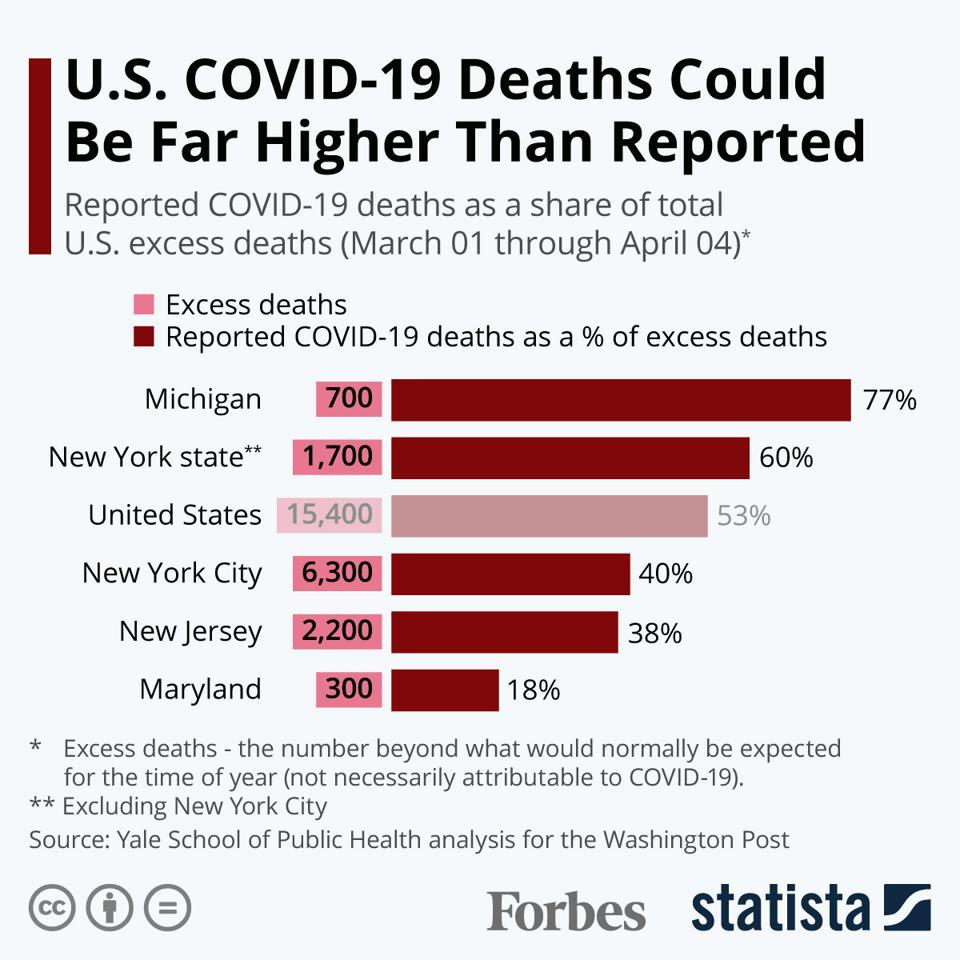Give some essential details in this illustration. According to the bar graph, in three places, the percentage of reported COVID-19 deaths is below 50%. The bar graph shows the number of excess deaths in different places, and in how many of those places is the number of excess deaths below 1000. Michigan has the highest reported percentage of COVID-19 deaths among all states, with over 65% of reported deaths being attributed to the virus. The bar graph depicts several places with varying numbers of excess deaths. The place with the third lowest number of excess deaths is New York state. In two locations, the percentage of reported COVID-19 deaths exceeds 55%. 